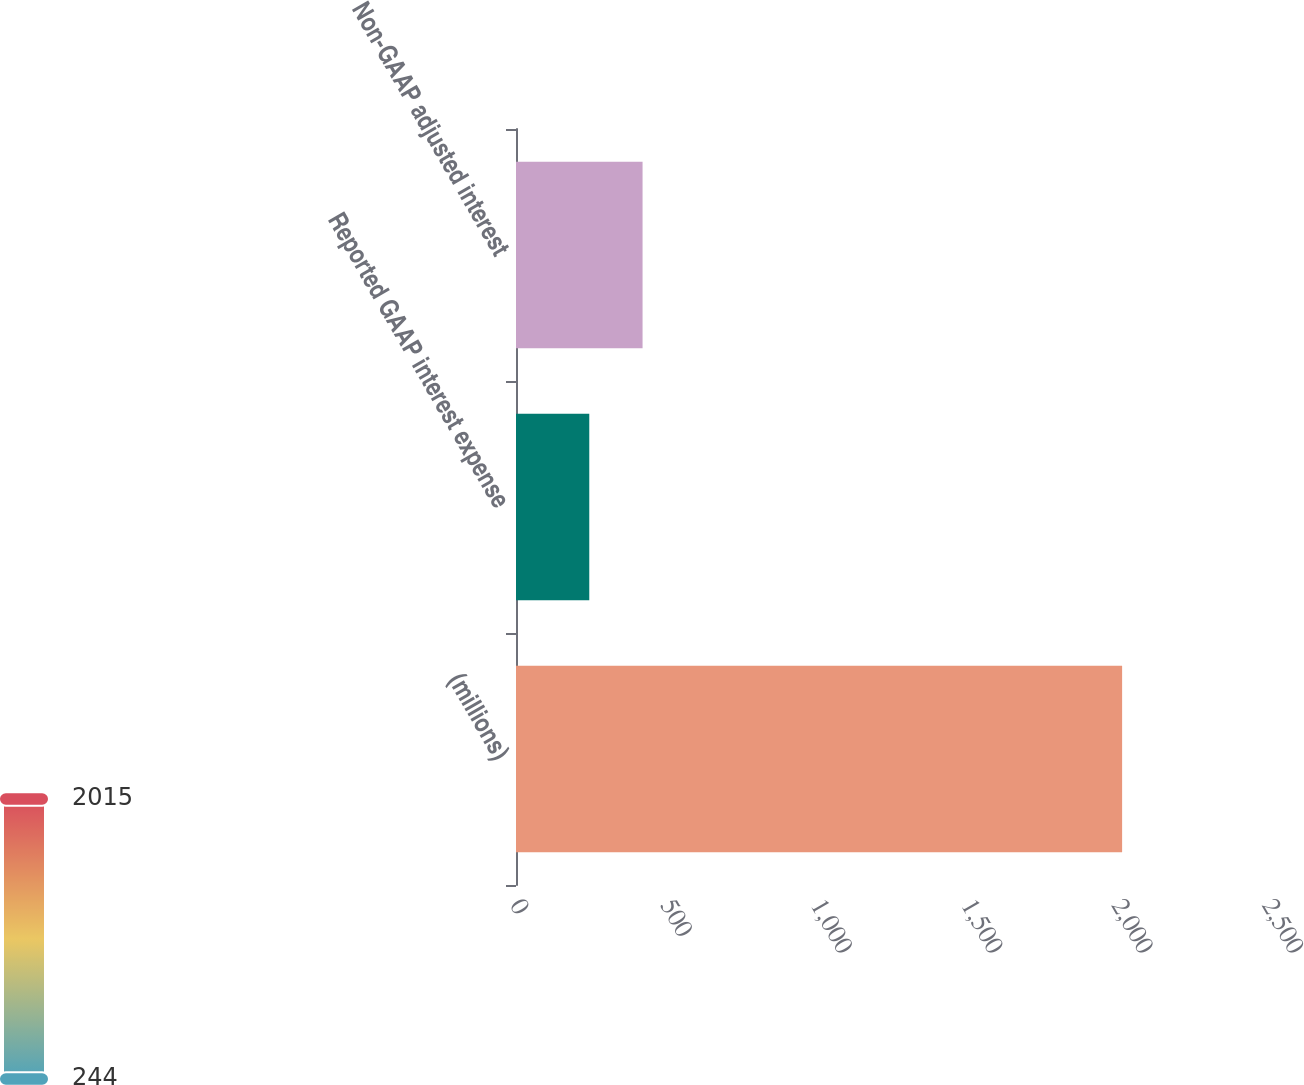Convert chart. <chart><loc_0><loc_0><loc_500><loc_500><bar_chart><fcel>(millions)<fcel>Reported GAAP interest expense<fcel>Non-GAAP adjusted interest<nl><fcel>2015<fcel>243.6<fcel>420.74<nl></chart> 